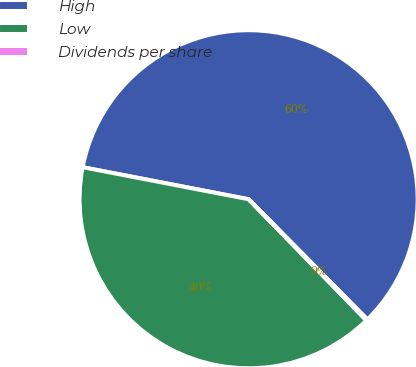<chart> <loc_0><loc_0><loc_500><loc_500><pie_chart><fcel>High<fcel>Low<fcel>Dividends per share<nl><fcel>59.56%<fcel>40.31%<fcel>0.13%<nl></chart> 